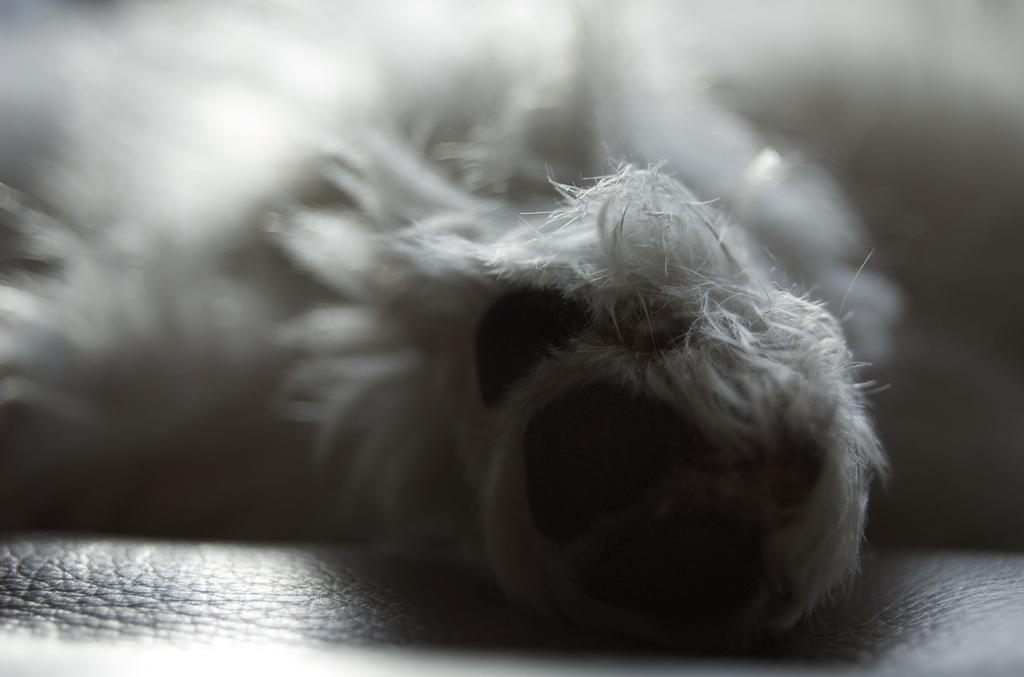What is the overall quality of the image? The image is blurry. What type of living creature can be seen in the image? There is an animal in the image. Where is the animal located in the image? The animal is on a sofa. How many eggs are visible on the sofa next to the animal in the image? There are no eggs visible in the image; it only features an animal on a sofa. What type of wealth is displayed by the animal in the image? There is no indication of wealth in the image; it simply shows an animal on a sofa. 